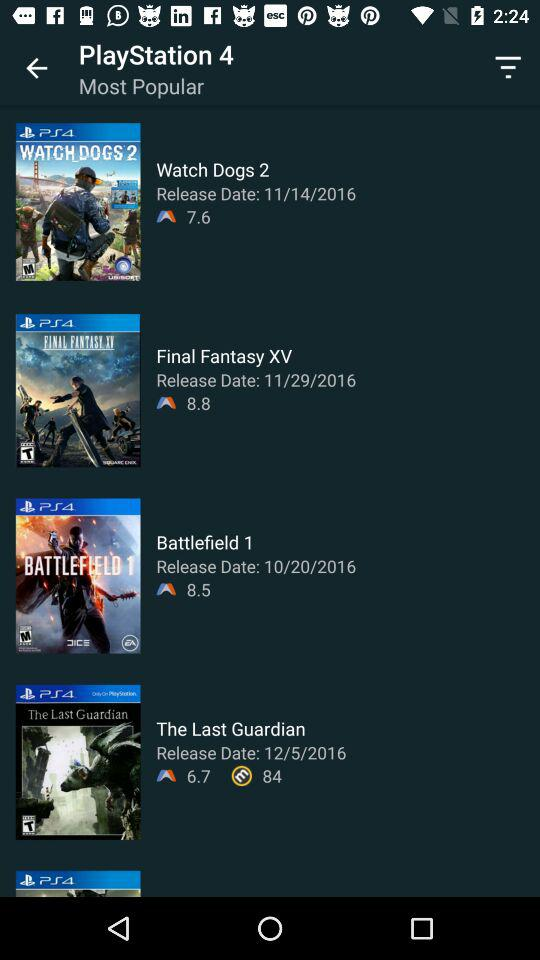What is the release date of "Battlefield 1"? The release date of "Battlefield 1" is October 20, 2016. 